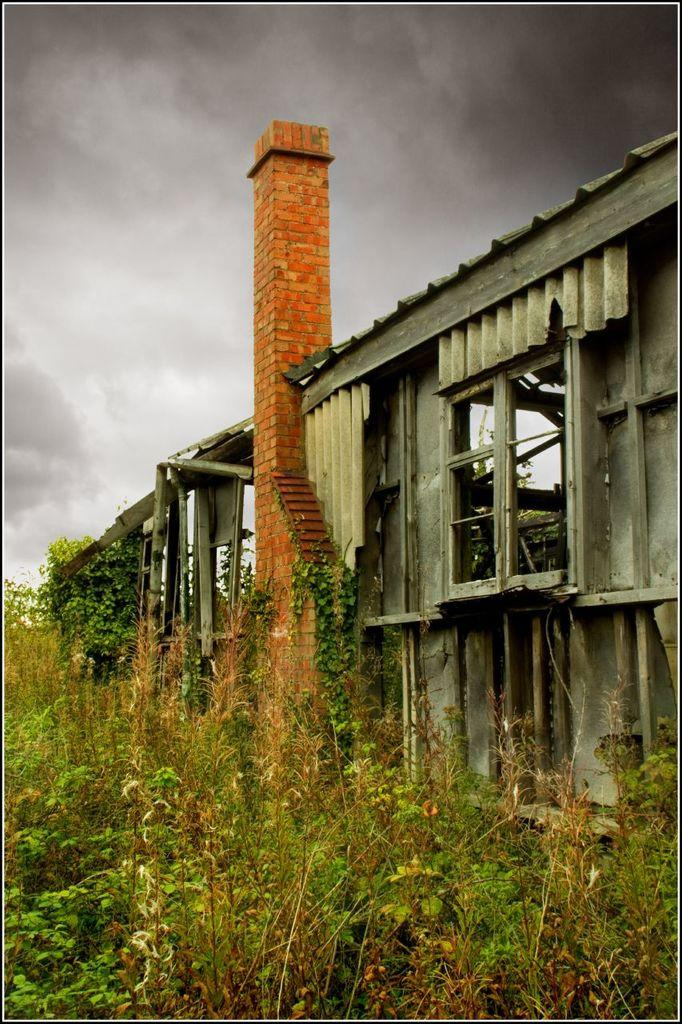What type of structure is visible in the image? There is a building with windows and a tower in the image. What can be seen in the foreground of the image? There is a group of plants in the foreground of the image. What is visible in the background of the image? The sky is visible in the background of the image. How would you describe the sky in the image? The sky appears to be cloudy in the image. What type of instrument is being played by the bird in the image? There is no bird or instrument present in the image. Who is serving the people in the image? There are no people or servants present in the image. 